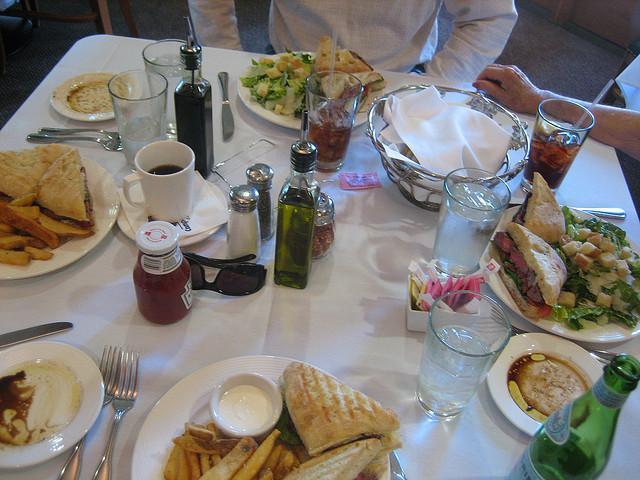How many plates of food are sitting on this white table?
Give a very brief answer. 7. How many baskets are on the table?
Give a very brief answer. 1. How many sandwiches can you see?
Give a very brief answer. 6. How many bowls are visible?
Give a very brief answer. 2. How many cups are visible?
Give a very brief answer. 7. How many people are in the picture?
Give a very brief answer. 2. How many bottles are in the picture?
Give a very brief answer. 4. How many birds are flying?
Give a very brief answer. 0. 